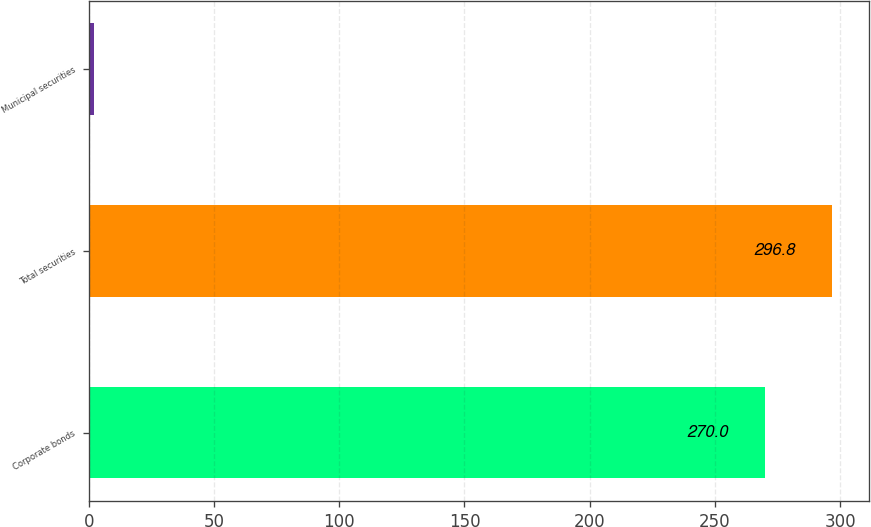<chart> <loc_0><loc_0><loc_500><loc_500><bar_chart><fcel>Corporate bonds<fcel>Total securities<fcel>Municipal securities<nl><fcel>270<fcel>296.8<fcel>2<nl></chart> 